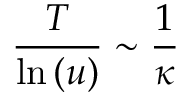Convert formula to latex. <formula><loc_0><loc_0><loc_500><loc_500>\frac { T } { \ln { ( u ) } } \sim \frac { 1 } { \kappa }</formula> 